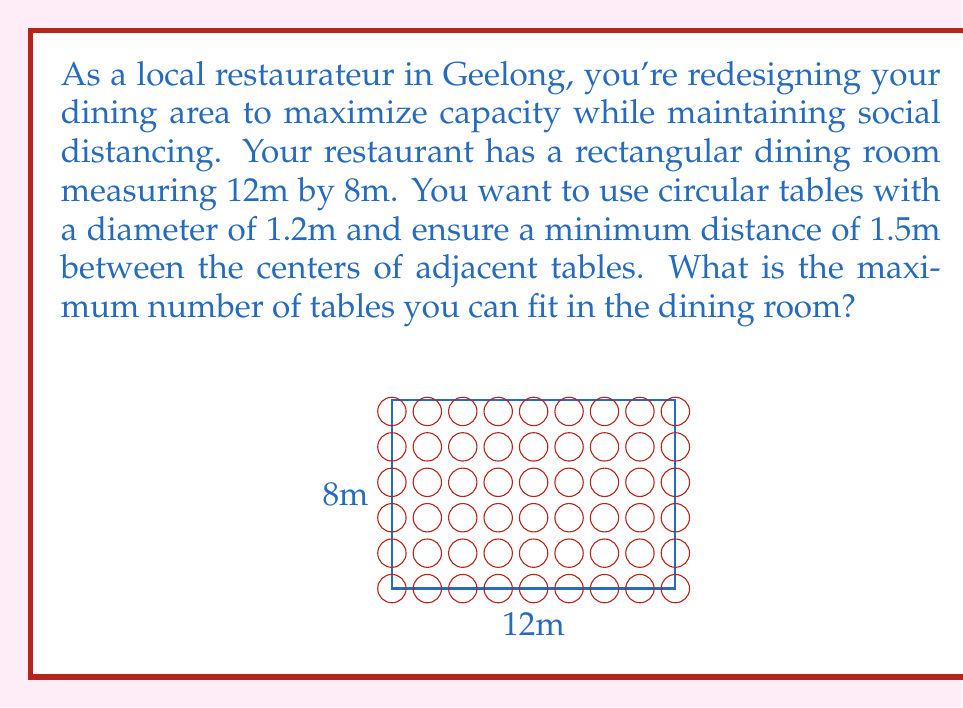What is the answer to this math problem? Let's approach this step-by-step:

1) First, we need to determine the minimum center-to-center distance between tables. This is the sum of the table diameter and the required spacing:
   
   $1.2m + 1.5m = 2.7m$

2) Now, we can calculate how many tables can fit along each dimension:

   Along the 12m side: $\frac{12m}{2.7m} \approx 4.44$
   Along the 8m side: $\frac{8m}{2.7m} \approx 2.96$

3) Since we can't have partial tables, we round down to the nearest whole number:

   4 tables along the 12m side
   2 tables along the 8m side

4) The total number of tables is the product of these two numbers:

   $4 * 2 = 8$ tables

5) We can verify this visually in the diagram, where we can see 8 circles (tables) fitting within the rectangle while maintaining the required spacing.

This arrangement maximizes the number of tables while adhering to the spacing requirements.
Answer: 8 tables 